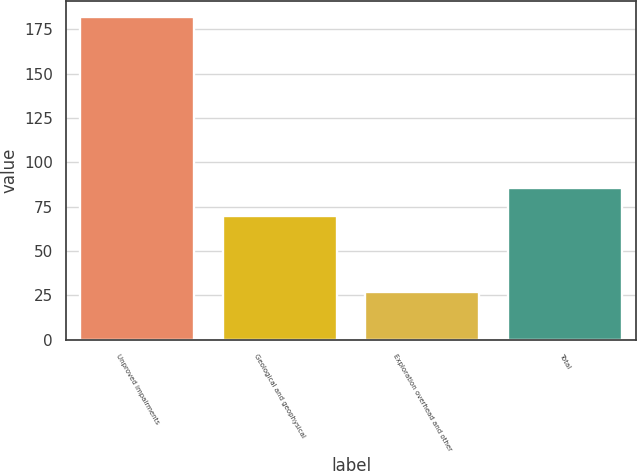Convert chart. <chart><loc_0><loc_0><loc_500><loc_500><bar_chart><fcel>Unproved impairments<fcel>Geological and geophysical<fcel>Exploration overhead and other<fcel>Total<nl><fcel>182<fcel>70<fcel>27<fcel>85.5<nl></chart> 